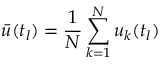Convert formula to latex. <formula><loc_0><loc_0><loc_500><loc_500>\bar { u } ( t _ { l } ) = \frac { 1 } { N } \sum _ { k = 1 } ^ { N } u _ { k } ( t _ { l } )</formula> 